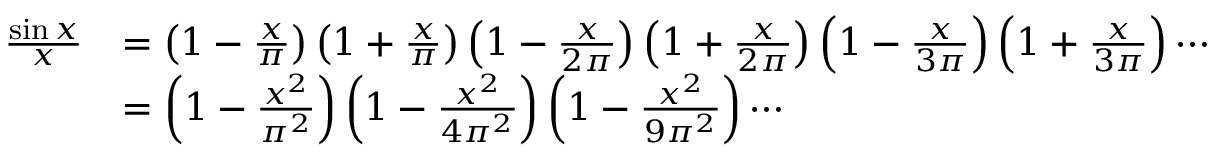<formula> <loc_0><loc_0><loc_500><loc_500>{ \begin{array} { r l } { { \frac { \sin x } { x } } } & { = \left ( 1 - { \frac { x } { \pi } } \right ) \left ( 1 + { \frac { x } { \pi } } \right ) \left ( 1 - { \frac { x } { 2 \pi } } \right ) \left ( 1 + { \frac { x } { 2 \pi } } \right ) \left ( 1 - { \frac { x } { 3 \pi } } \right ) \left ( 1 + { \frac { x } { 3 \pi } } \right ) \cdots } \\ & { = \left ( 1 - { \frac { x ^ { 2 } } { \pi ^ { 2 } } } \right ) \left ( 1 - { \frac { x ^ { 2 } } { 4 \pi ^ { 2 } } } \right ) \left ( 1 - { \frac { x ^ { 2 } } { 9 \pi ^ { 2 } } } \right ) \cdots } \end{array} }</formula> 